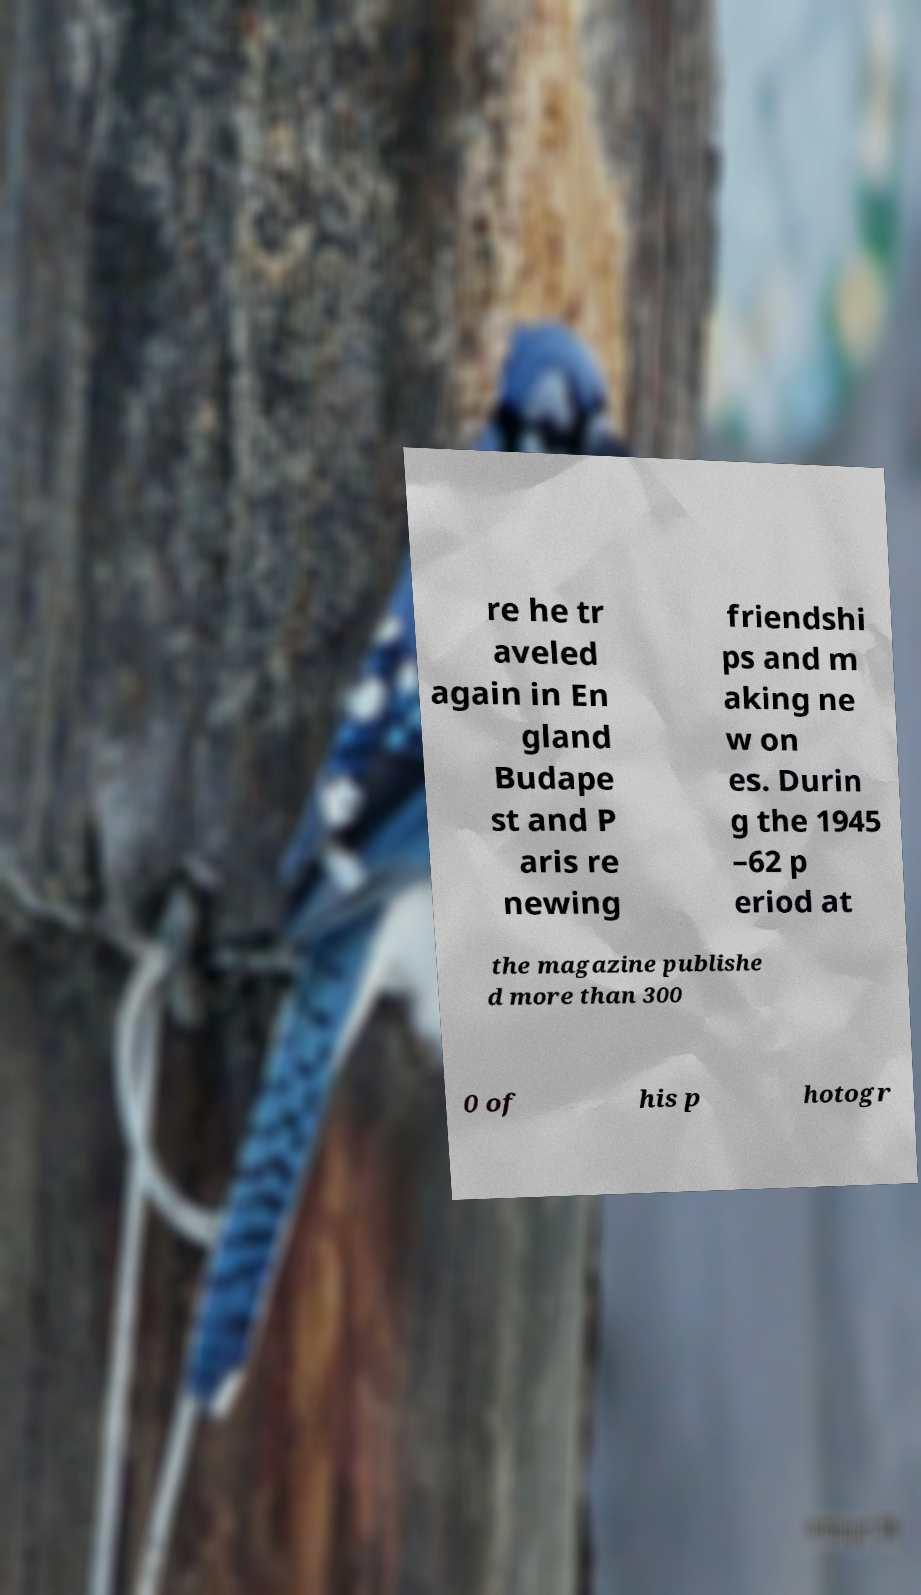Can you accurately transcribe the text from the provided image for me? re he tr aveled again in En gland Budape st and P aris re newing friendshi ps and m aking ne w on es. Durin g the 1945 –62 p eriod at the magazine publishe d more than 300 0 of his p hotogr 